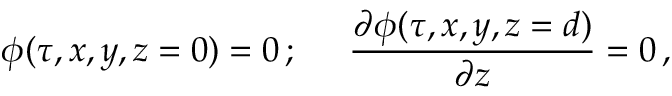Convert formula to latex. <formula><loc_0><loc_0><loc_500><loc_500>\phi ( \tau , x , y , z = 0 ) = 0 \, ; \, { \frac { \partial \phi ( \tau , x , y , z = d ) } { \partial z } } = 0 \, ,</formula> 